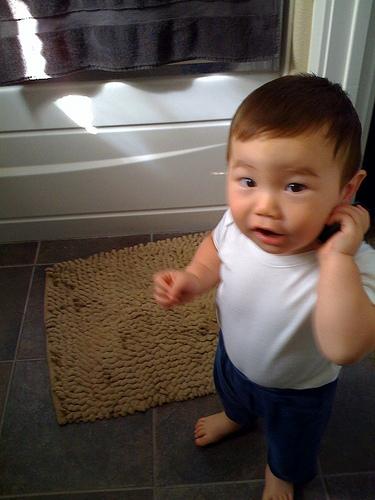Is the baby standing?
Give a very brief answer. Yes. Is there a rug on the floor?
Short answer required. Yes. Is the baby smiling?
Concise answer only. No. What is the boy learning to do?
Concise answer only. Walk. 